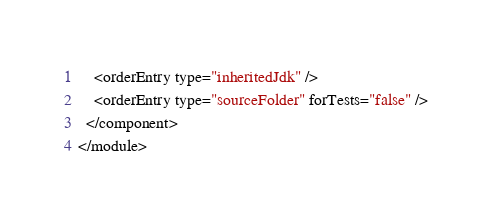<code> <loc_0><loc_0><loc_500><loc_500><_XML_>    <orderEntry type="inheritedJdk" />
    <orderEntry type="sourceFolder" forTests="false" />
  </component>
</module></code> 